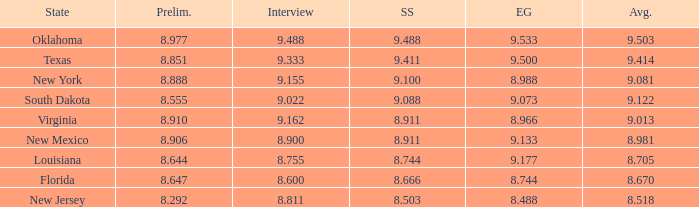 what's the swimsuit where average is 8.670 8.666. 